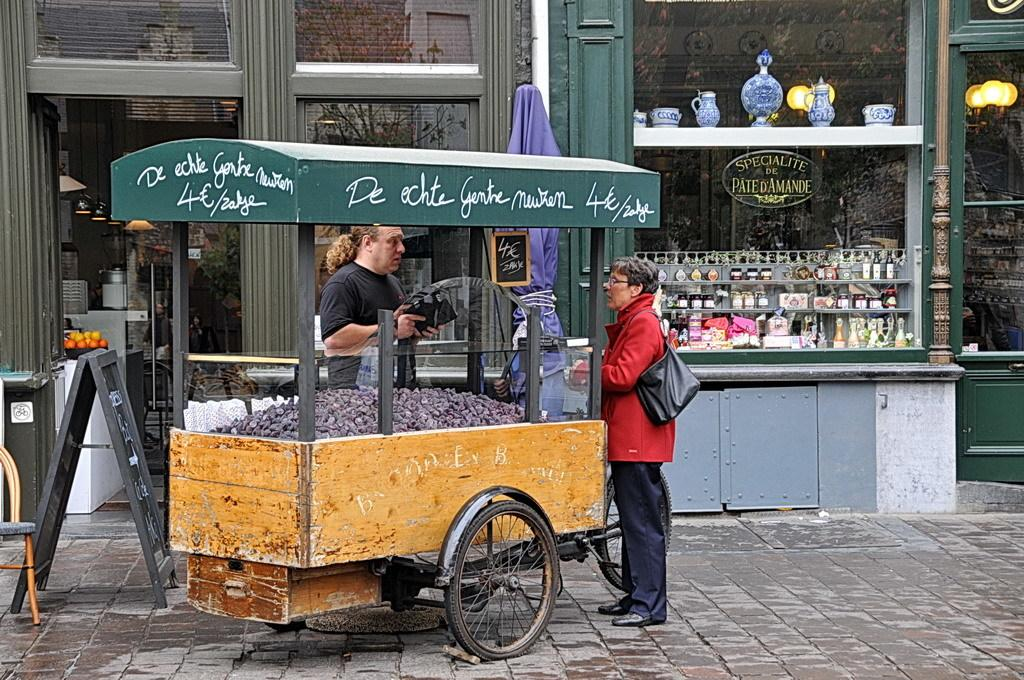How many people are present in the image? There are two people standing in the image. What is one person wearing in the image? One person is wearing a bag. What objects can be seen in the image besides the people? There is a cart, a board, a chair, a stall, and glass visible in the image. What is visible through the glass in the background of the image? Trees and lights are visible through the glass. Can you tell me how much credit the person with the bag has in the image? There is no information about credit or finances in the image; it only shows two people, a cart, a board, a chair, a stall, glass, trees, and lights. Is there any steam coming from the person's neck in the image? There is no steam or any indication of heat or steam in the image; it is a scene with people, objects, and a background. 